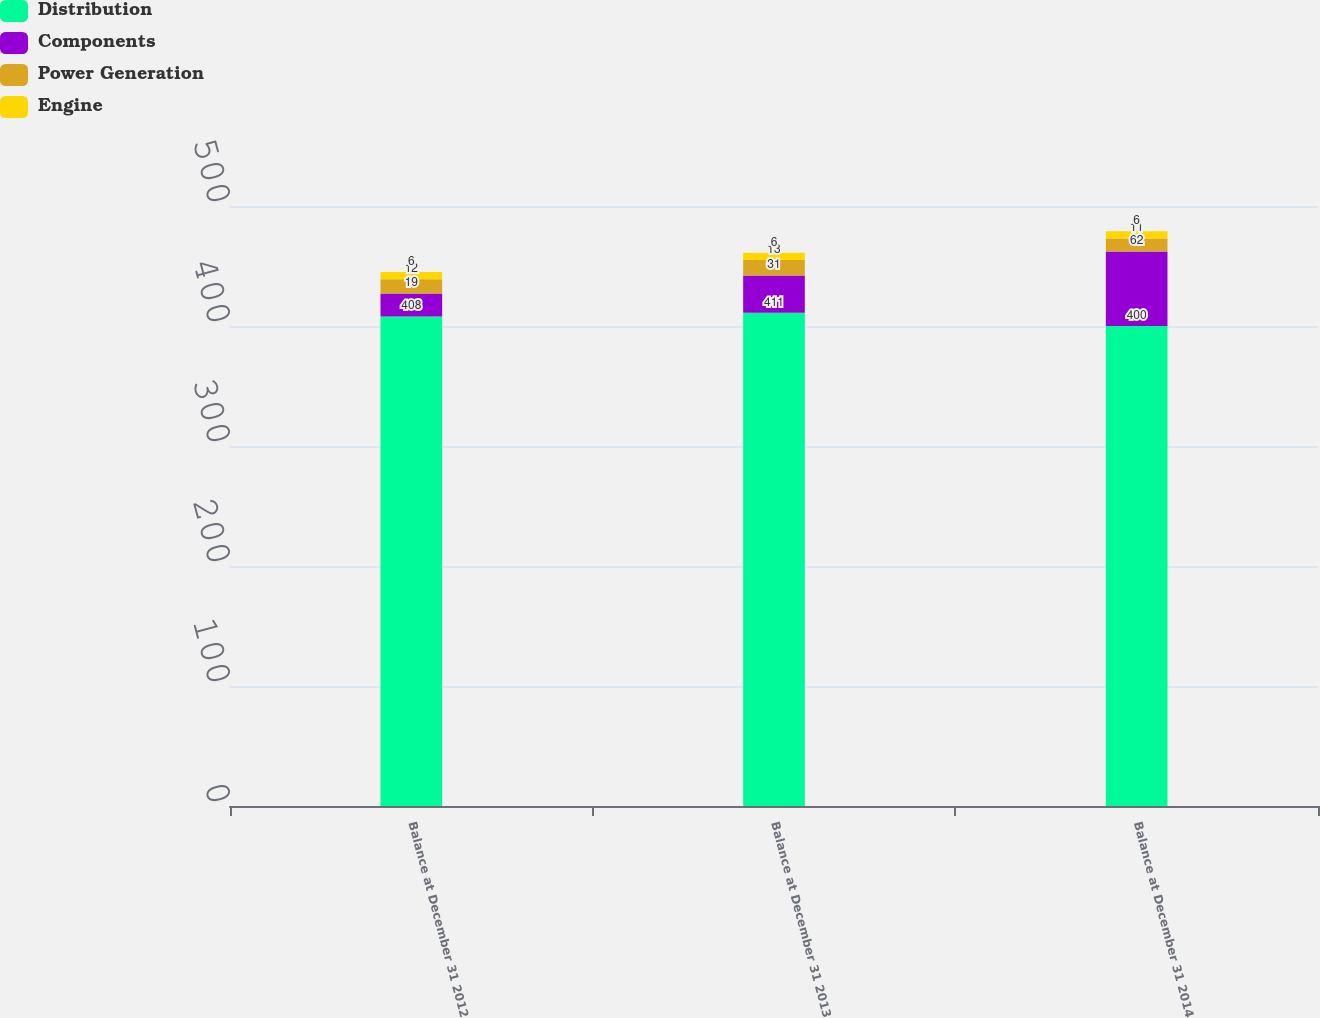Convert chart. <chart><loc_0><loc_0><loc_500><loc_500><stacked_bar_chart><ecel><fcel>Balance at December 31 2012<fcel>Balance at December 31 2013<fcel>Balance at December 31 2014<nl><fcel>Distribution<fcel>408<fcel>411<fcel>400<nl><fcel>Components<fcel>19<fcel>31<fcel>62<nl><fcel>Power Generation<fcel>12<fcel>13<fcel>11<nl><fcel>Engine<fcel>6<fcel>6<fcel>6<nl></chart> 